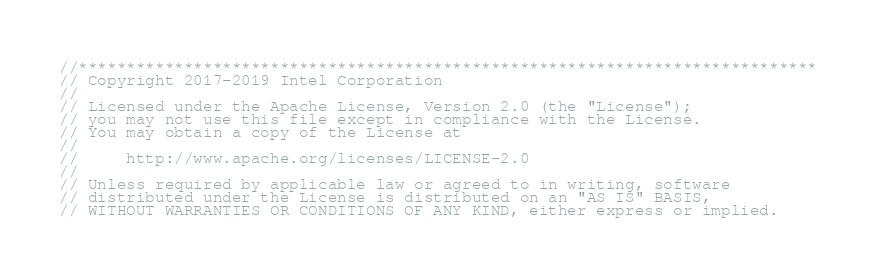Convert code to text. <code><loc_0><loc_0><loc_500><loc_500><_C++_>//*****************************************************************************
// Copyright 2017-2019 Intel Corporation
//
// Licensed under the Apache License, Version 2.0 (the "License");
// you may not use this file except in compliance with the License.
// You may obtain a copy of the License at
//
//     http://www.apache.org/licenses/LICENSE-2.0
//
// Unless required by applicable law or agreed to in writing, software
// distributed under the License is distributed on an "AS IS" BASIS,
// WITHOUT WARRANTIES OR CONDITIONS OF ANY KIND, either express or implied.</code> 